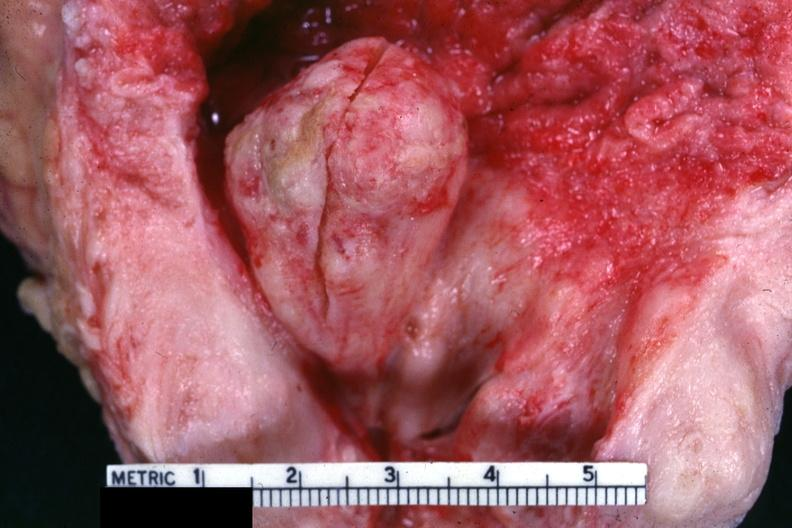what is present?
Answer the question using a single word or phrase. Prostate 